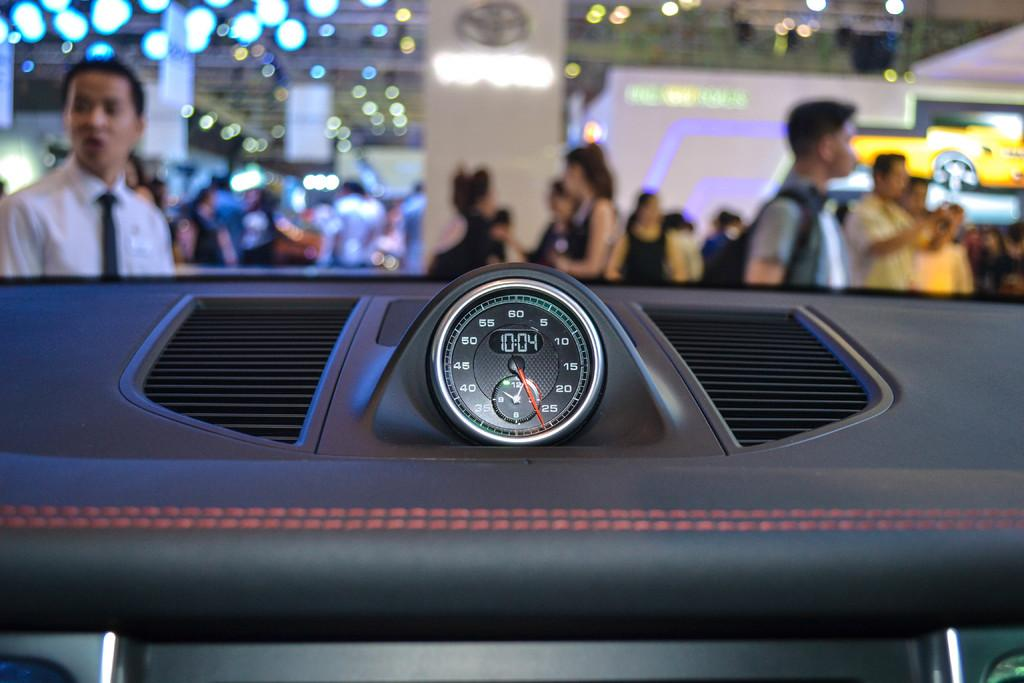What device is present in the image that measures speed? There is a speedometer in the image. Can you describe the people in the image? There is a group of people in the image. What type of objects are present in the image that can be used for displaying information or messages? There are boards in the image. What type of illumination is present in the image? There are lights in the image. What type of spade is being used by the people in the image? There is no spade present in the image. What type of humor can be observed in the image? There is no humor present in the image; it is a straightforward depiction of the subjects and objects mentioned in the facts. 